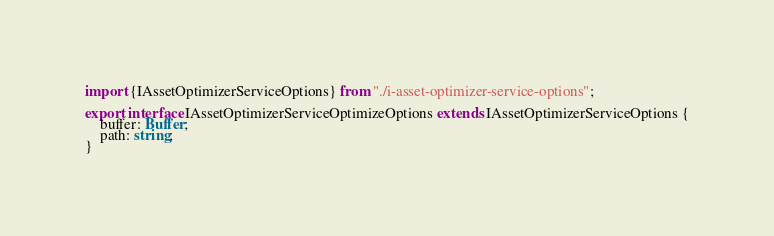Convert code to text. <code><loc_0><loc_0><loc_500><loc_500><_TypeScript_>import {IAssetOptimizerServiceOptions} from "./i-asset-optimizer-service-options";

export interface IAssetOptimizerServiceOptimizeOptions extends IAssetOptimizerServiceOptions {
	buffer: Buffer;
	path: string;
}</code> 